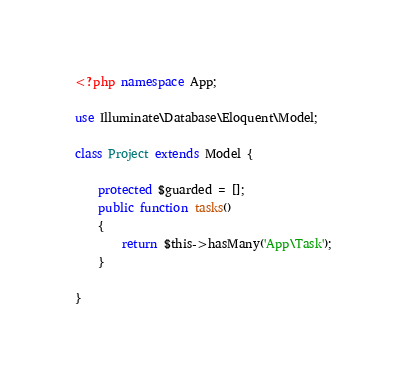<code> <loc_0><loc_0><loc_500><loc_500><_PHP_><?php namespace App;

use Illuminate\Database\Eloquent\Model;

class Project extends Model {

    protected $guarded = [];
	public function tasks()
    {
        return $this->hasMany('App\Task');
    }

}
</code> 